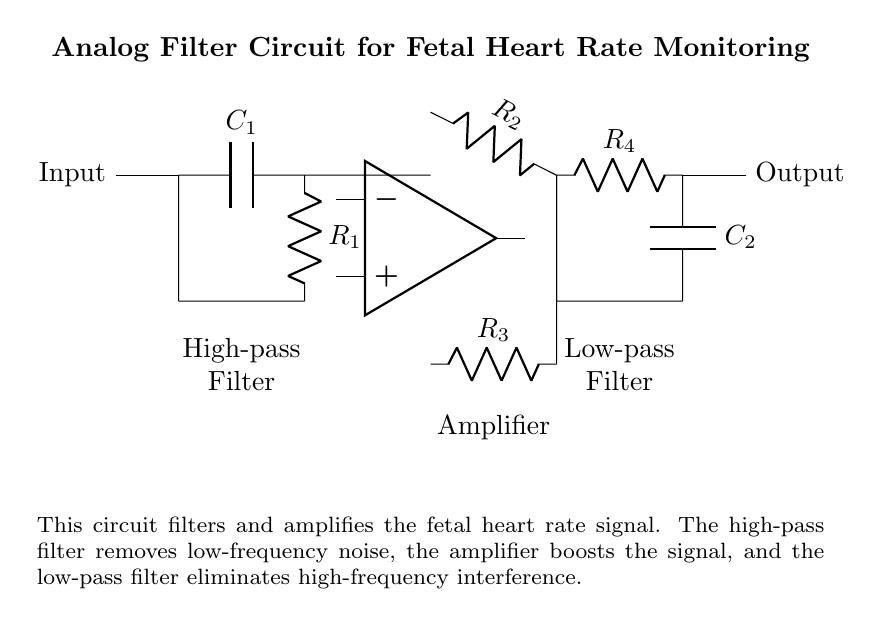What type of filter is represented at the input? The circuit includes a high-pass filter, which is indicated by the capacitor and resistor combination placed at the input section. The capacitor blocks low frequencies, allowing higher frequencies to pass through.
Answer: High-pass filter What components make up the amplifier stage? The amplifier stage consists of an operational amplifier along with two resistors (R2 and R3). The op amp serves as the main amplification element, while the resistors are used for feedback and to set the gain of the amplifier.
Answer: Op amp, R2, R3 What is the overall function of the circuit? The circuit's main function is to filter and amplify the fetal heart rate signal. It first removes unwanted low and high-frequency noises, ensuring only the relevant fetal heart rate frequencies are enhanced for monitoring.
Answer: Filtering and amplifying fetal heart rate How many resistors are in this circuit? The circuit has four resistors in total: R1, R2, R3, and R4, each serving unique functions such as noise filtering and signal amplification.
Answer: Four Why is a low-pass filter used at the output? A low-pass filter is used to eliminate high-frequency interference from the fetal heart rate signal. It allows lower frequencies, which are more relevant for fetal monitoring, to pass while blocking excessive higher frequencies that could distort the signal.
Answer: To eliminate high-frequency interference What is the role of capacitor C1 in this circuit? Capacitor C1 is part of the high-pass filter and its role is to block low-frequency signals, which helps reduce noise artifacts below the desired frequency range from the fetal heart rate signal.
Answer: Block low frequencies What do the labels on resistors R2 and R3 indicate about their function? The labels indicate that R2 is part of the feedback loop for the amplifier, helping to set its gain, while R3 is likely designed to stabilize the circuit by controlling current and voltage levels.
Answer: Feedback control (R2), stability (R3) 